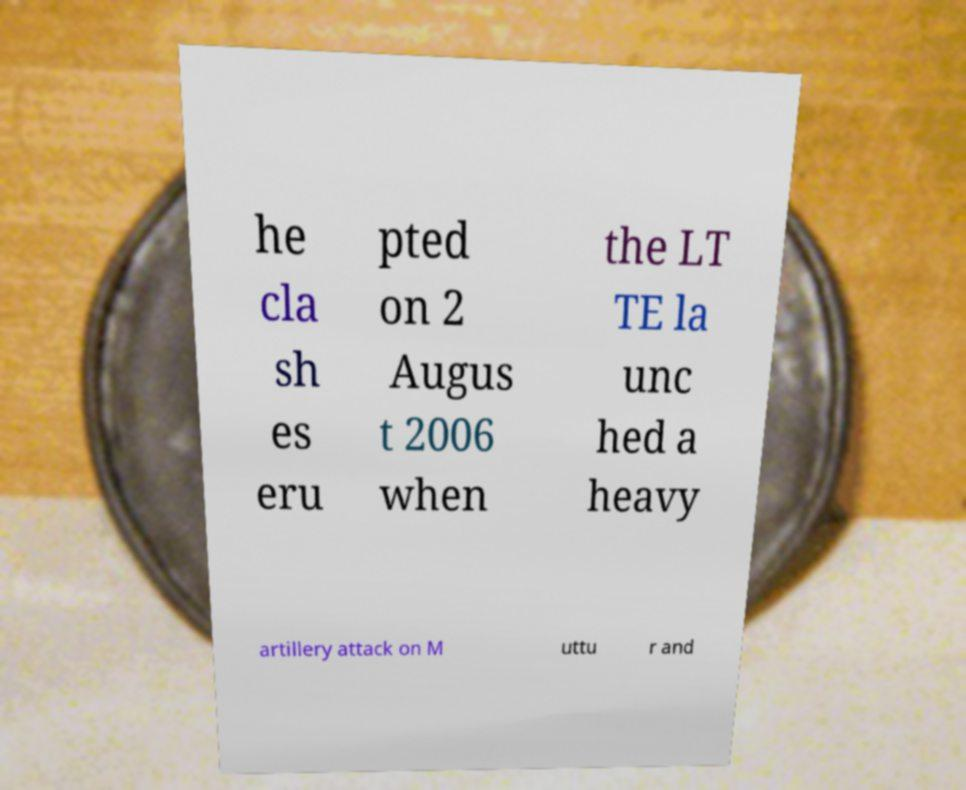Could you extract and type out the text from this image? he cla sh es eru pted on 2 Augus t 2006 when the LT TE la unc hed a heavy artillery attack on M uttu r and 